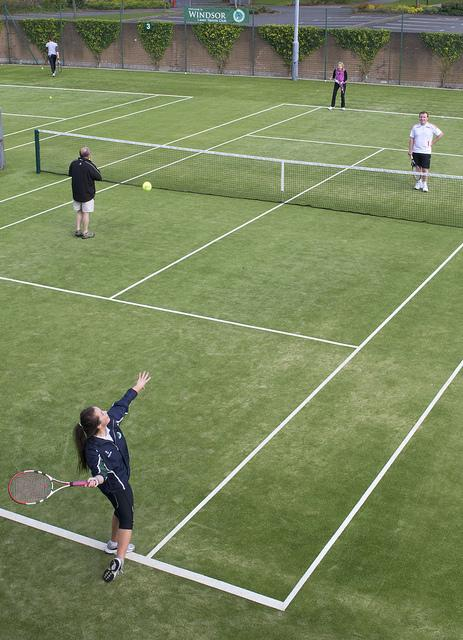What is the minimum number of players who can partake in a match of this sport? Please explain your reasoning. two. It is called singles. where there is one person on each side of the net. 